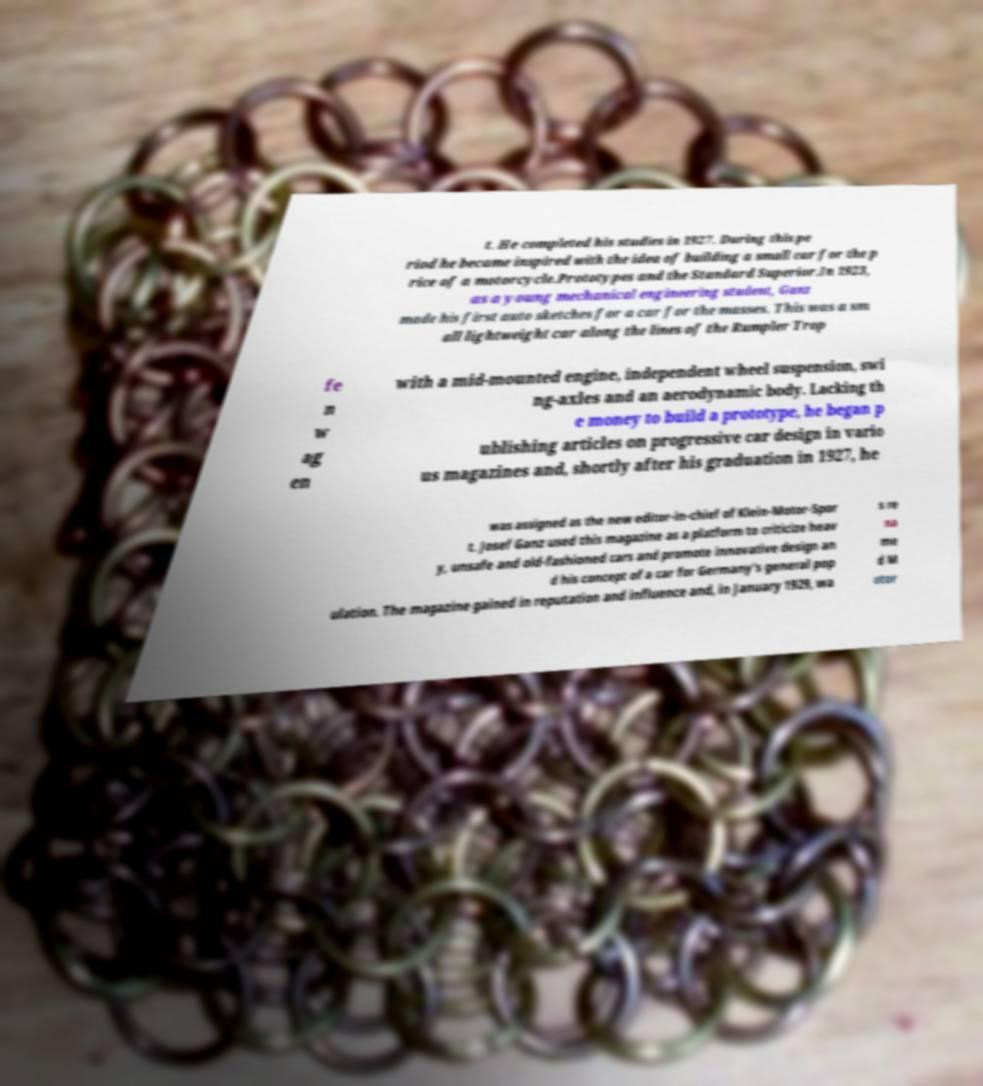Could you assist in decoding the text presented in this image and type it out clearly? t. He completed his studies in 1927. During this pe riod he became inspired with the idea of building a small car for the p rice of a motorcycle.Prototypes and the Standard Superior.In 1923, as a young mechanical engineering student, Ganz made his first auto sketches for a car for the masses. This was a sm all lightweight car along the lines of the Rumpler Trop fe n w ag en with a mid-mounted engine, independent wheel suspension, swi ng-axles and an aerodynamic body. Lacking th e money to build a prototype, he began p ublishing articles on progressive car design in vario us magazines and, shortly after his graduation in 1927, he was assigned as the new editor-in-chief of Klein-Motor-Spor t. Josef Ganz used this magazine as a platform to criticize heav y, unsafe and old-fashioned cars and promote innovative design an d his concept of a car for Germany's general pop ulation. The magazine gained in reputation and influence and, in January 1929, wa s re na me d M otor 